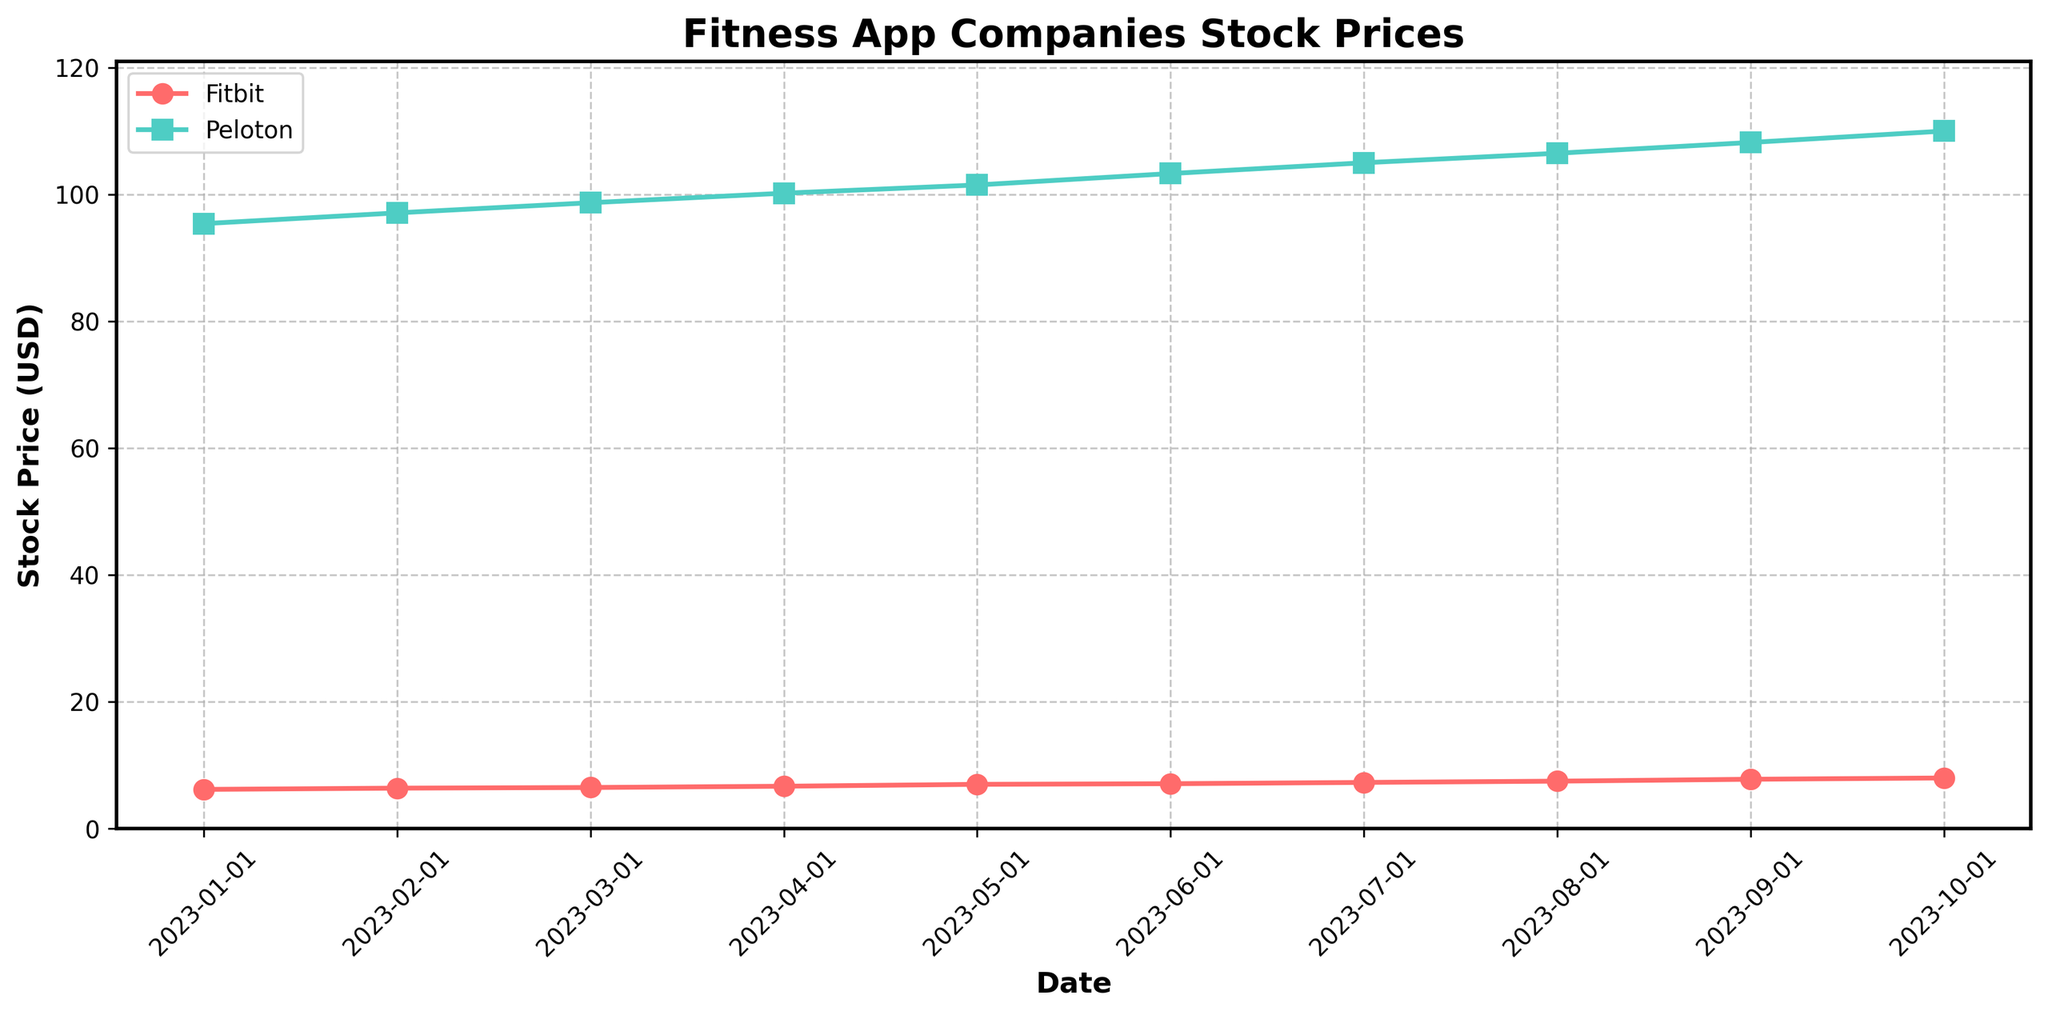What is the title of the plot? The title of the plot is displayed prominently at the top of the figure. It helps to understand the context of the data being visualized.
Answer: Fitness App Companies Stock Prices What are the two companies shown in the plot? The two companies are indicated by different colors and markers in the plot and are also listed in the legend.
Answer: Fitbit and Peloton Which company had a higher stock price on 2023-08-01? To find this, look for the data points corresponding to the date 2023-08-01 and compare the stock prices.
Answer: Peloton When did Fitbit's stock price reach 7.0 USD? The date when Fitbit's stock price reached 7.0 USD can be found on the x-axis aligned with the stock price line.
Answer: May 2023 How much did Peloton's stock price increase from 2023-01-01 to 2023-10-01? Find Peloton's stock prices on 2023-01-01 and 2023-10-01 and calculate the difference.
Answer: 14.6 USD On which dates did both companies have increases in their stock prices? Scan through the plotted lines and look for dates where both companies' lines slope upward.
Answer: Multiple dates, including February 2023, March 2023, April 2023, etc What is the average stock price of Fitbit across all dates shown in the plot? Sum up all the stock prices for Fitbit and divide by the number of data points for Fitbit.
Answer: 7.0 USD Which company showed a more consistent growth in stock prices throughout the plotted period? By observing the trend lines, determine which company's line has a steadier upward slope.
Answer: Fitbit How does the stock price trend of Fitbit compare to the new user acquisition rate trend over time? Observe the correlation and pattern between the Fitbit stock price and the new user acquisition rate trends from the data.
Answer: Both trends generally increase over time During which month did Peloton experience its highest monthly increase in stock price? How much was this increase? Compare the month-over-month changes in Peloton's stock prices and identify the greatest change and the corresponding month.
Answer: July 2023, with an increase of 1.7 USD 